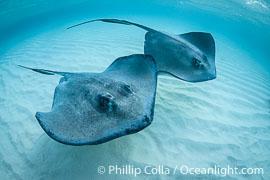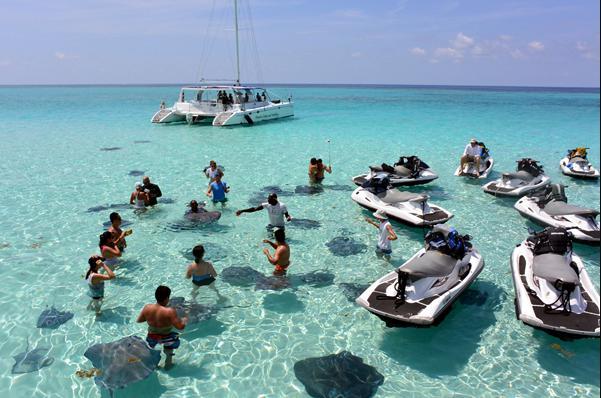The first image is the image on the left, the second image is the image on the right. For the images displayed, is the sentence "The right image shows no human beings." factually correct? Answer yes or no. No. The first image is the image on the left, the second image is the image on the right. Examine the images to the left and right. Is the description "The image on the left is taken from out of the water, and the image on the right is taken from in the water." accurate? Answer yes or no. No. 